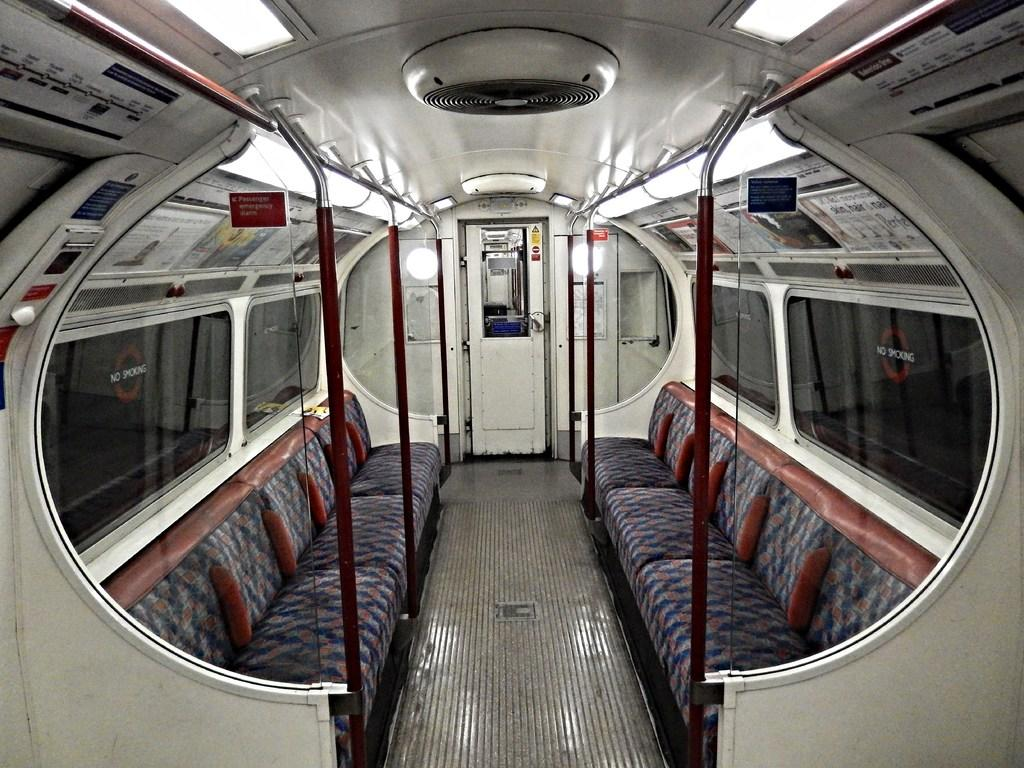What type of setting is depicted in the image? The image is inside a vehicle. What can be seen in the vehicle? There are lights, poles, a door, glass windows, and couches in the vehicle. How are the windows of the vehicle made? The windows of the vehicle are made of glass. What might be used for seating in the vehicle? Couches are present in the vehicle for seating. Can you tell me how many doctors are present in the image? There are no doctors present in the image; it is inside a vehicle with various objects and features. What type of bed can be seen in the image? There is no bed present in the image; it features a vehicle with lights, poles, a door, glass windows, and couches. 